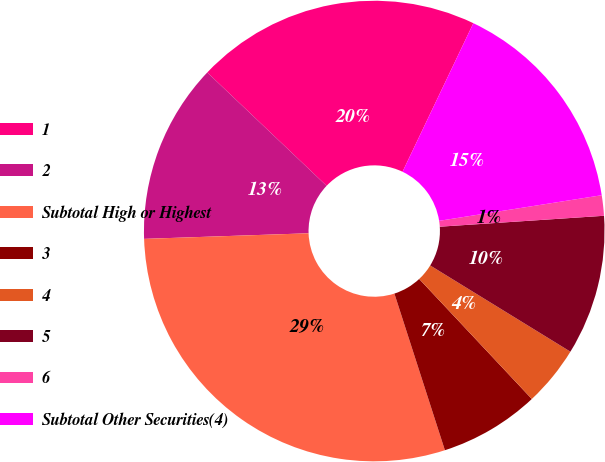Convert chart. <chart><loc_0><loc_0><loc_500><loc_500><pie_chart><fcel>1<fcel>2<fcel>Subtotal High or Highest<fcel>3<fcel>4<fcel>5<fcel>6<fcel>Subtotal Other Securities(4)<nl><fcel>19.99%<fcel>12.63%<fcel>29.42%<fcel>7.03%<fcel>4.23%<fcel>9.83%<fcel>1.43%<fcel>15.43%<nl></chart> 